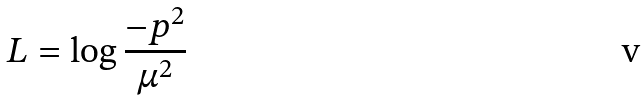<formula> <loc_0><loc_0><loc_500><loc_500>L = \log \frac { - p ^ { 2 } } { \mu ^ { 2 } }</formula> 